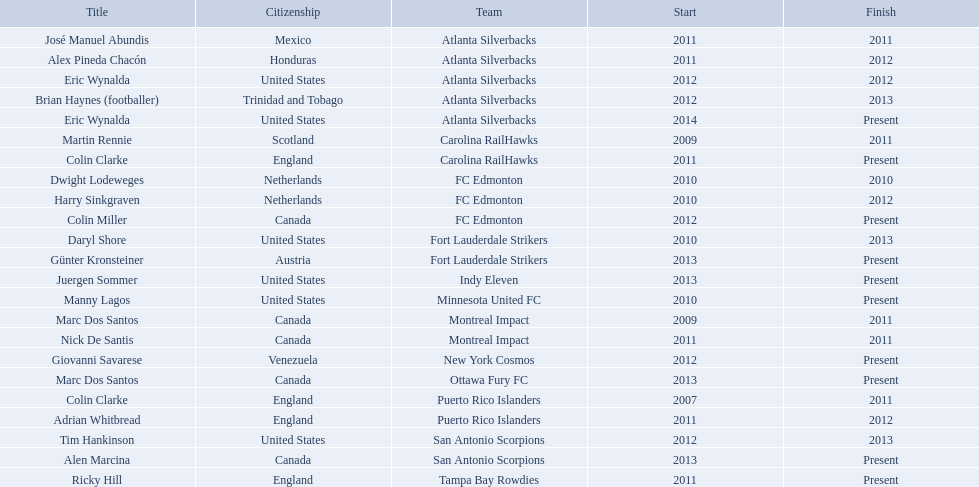What were all the coaches who were coaching in 2010? Martin Rennie, Dwight Lodeweges, Harry Sinkgraven, Daryl Shore, Manny Lagos, Marc Dos Santos, Colin Clarke. Which of the 2010 coaches were not born in north america? Martin Rennie, Dwight Lodeweges, Harry Sinkgraven, Colin Clarke. Which coaches that were coaching in 2010 and were not from north america did not coach for fc edmonton? Martin Rennie, Colin Clarke. What coach did not coach for fc edmonton in 2010 and was not north american nationality had the shortened career as a coach? Martin Rennie. 